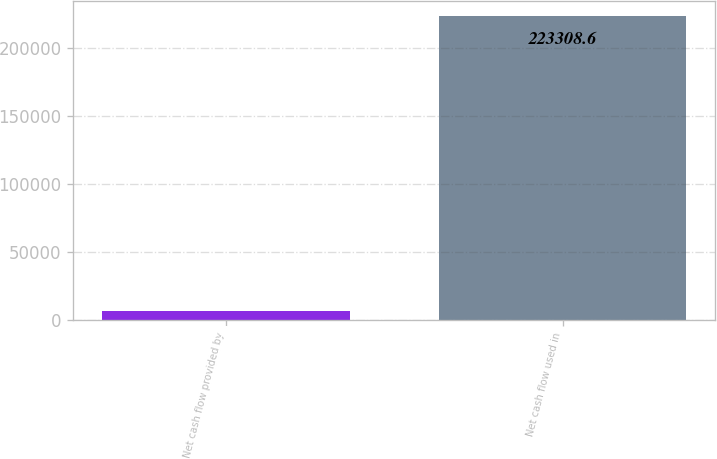Convert chart to OTSL. <chart><loc_0><loc_0><loc_500><loc_500><bar_chart><fcel>Net cash flow provided by<fcel>Net cash flow used in<nl><fcel>6672<fcel>223309<nl></chart> 